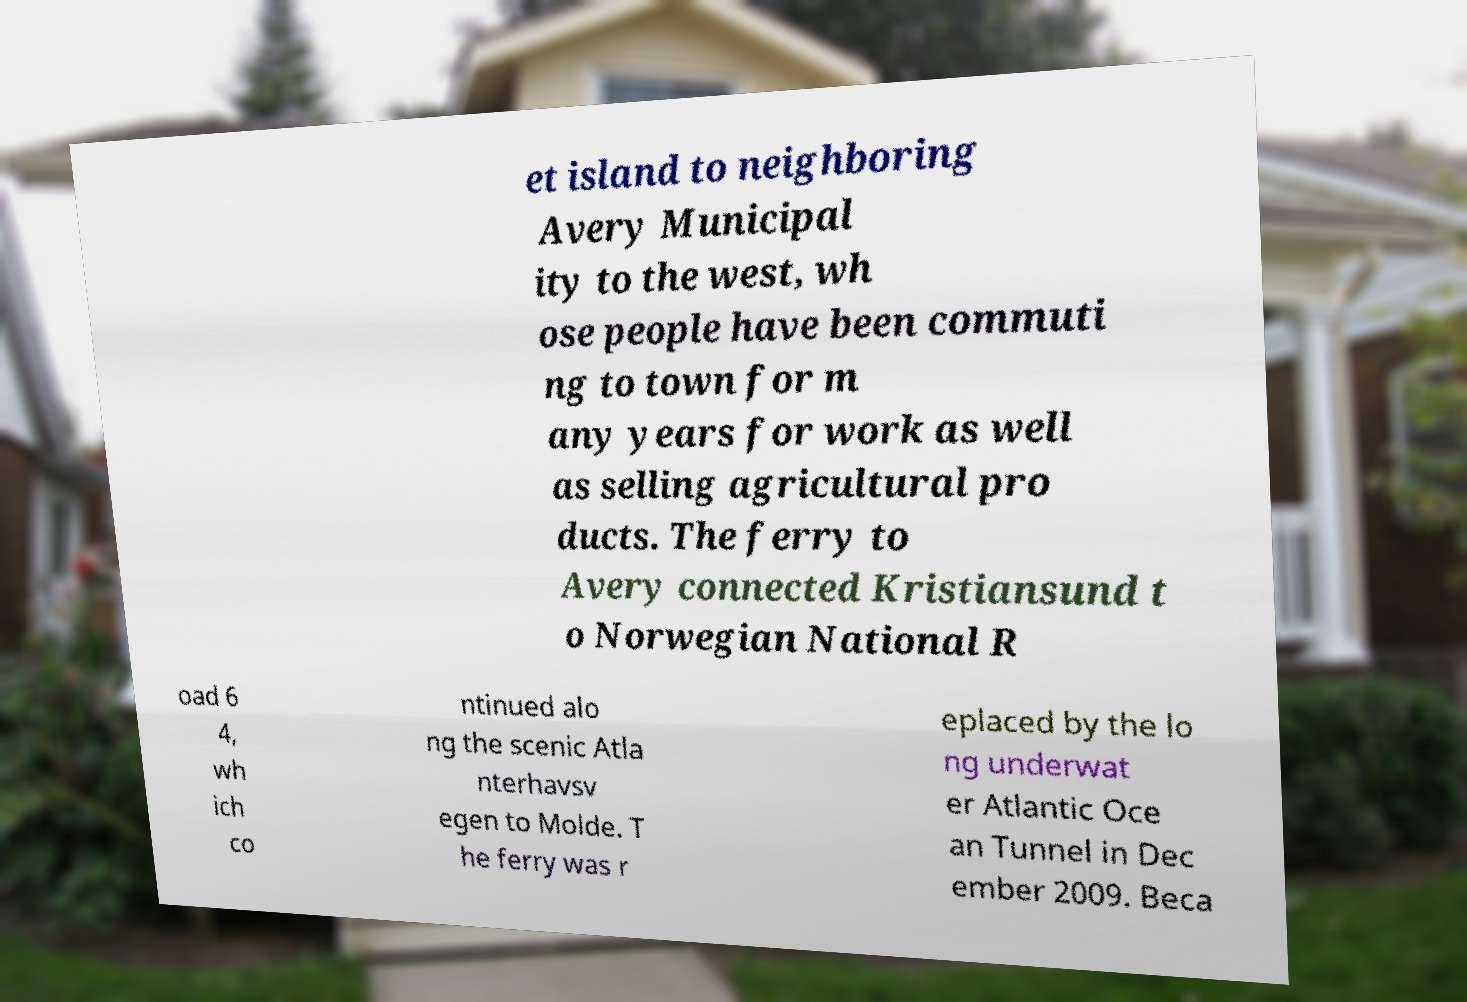There's text embedded in this image that I need extracted. Can you transcribe it verbatim? et island to neighboring Avery Municipal ity to the west, wh ose people have been commuti ng to town for m any years for work as well as selling agricultural pro ducts. The ferry to Avery connected Kristiansund t o Norwegian National R oad 6 4, wh ich co ntinued alo ng the scenic Atla nterhavsv egen to Molde. T he ferry was r eplaced by the lo ng underwat er Atlantic Oce an Tunnel in Dec ember 2009. Beca 